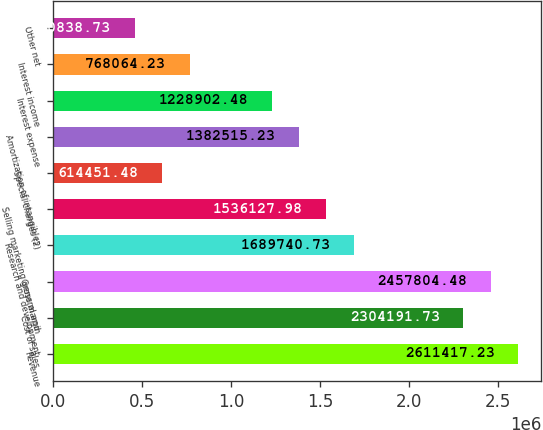Convert chart to OTSL. <chart><loc_0><loc_0><loc_500><loc_500><bar_chart><fcel>Revenue<fcel>Cost of sales<fcel>Gross margin<fcel>Research and development<fcel>Selling marketing general and<fcel>Special charges (2)<fcel>Amortization of intangibles<fcel>Interest expense<fcel>Interest income<fcel>Other net<nl><fcel>2.61142e+06<fcel>2.30419e+06<fcel>2.4578e+06<fcel>1.68974e+06<fcel>1.53613e+06<fcel>614451<fcel>1.38252e+06<fcel>1.2289e+06<fcel>768064<fcel>460839<nl></chart> 